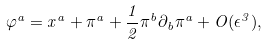<formula> <loc_0><loc_0><loc_500><loc_500>\varphi ^ { a } = x ^ { a } + \pi ^ { a } + \frac { 1 } { 2 } \pi ^ { b } \partial _ { b } \pi ^ { a } + O ( \epsilon ^ { 3 } ) ,</formula> 